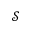<formula> <loc_0><loc_0><loc_500><loc_500>\mathcal { S }</formula> 